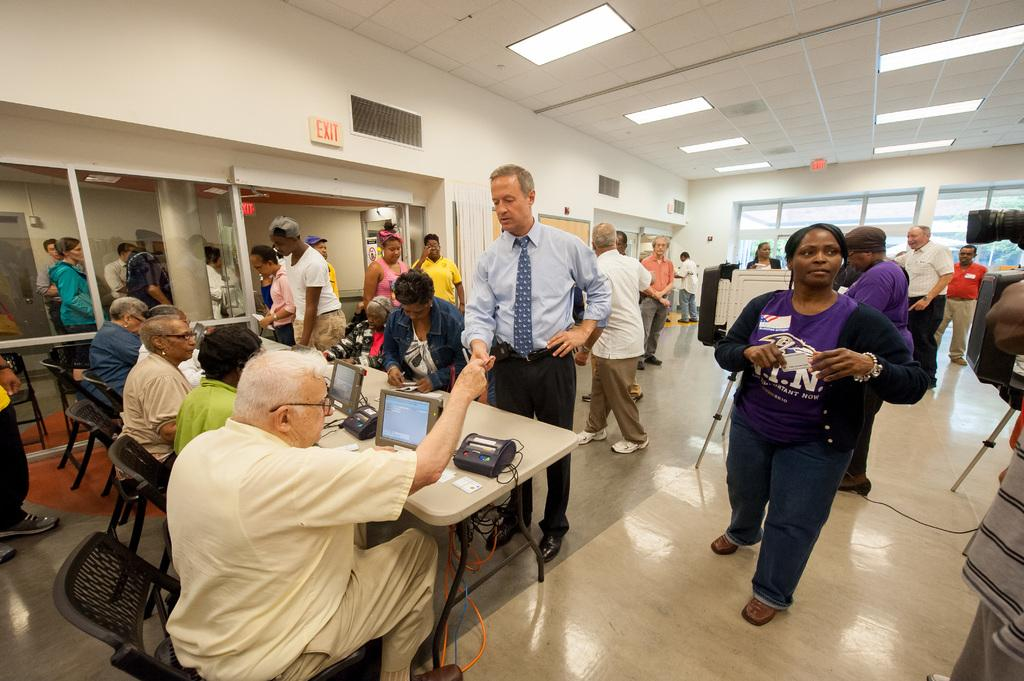Provide a one-sentence caption for the provided image. A group of people are in a room some sitting using computers andsome standing and there is an exit sign on the wall. 